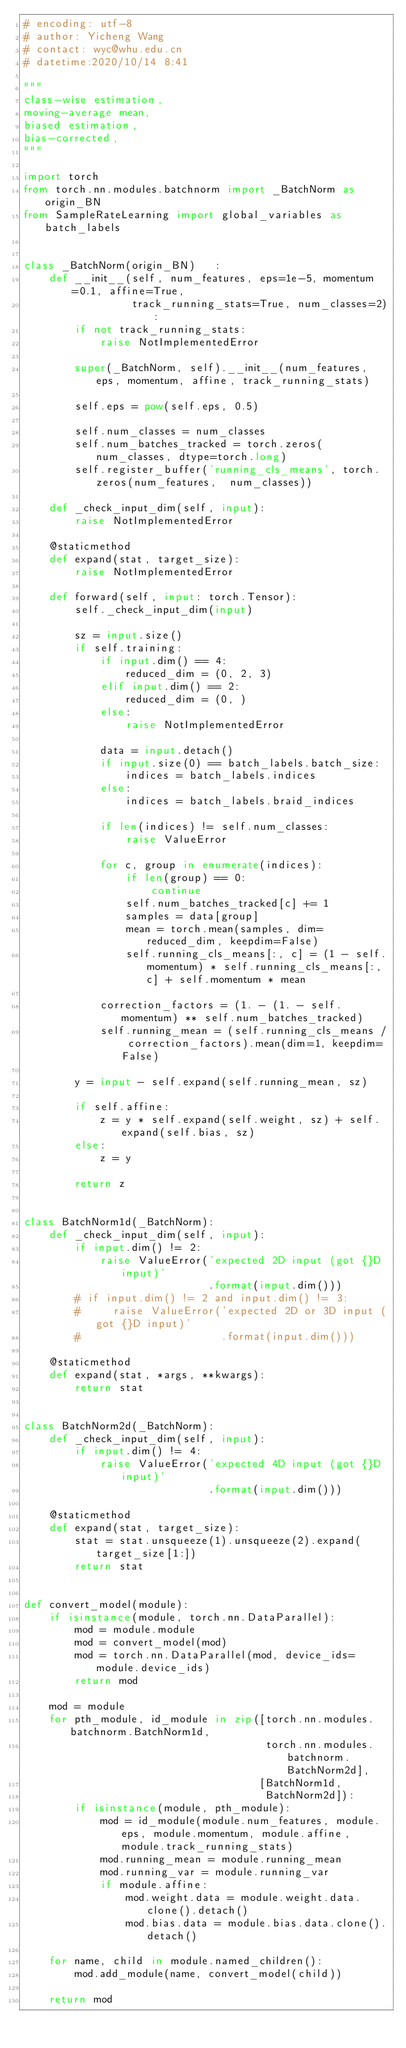<code> <loc_0><loc_0><loc_500><loc_500><_Python_># encoding: utf-8
# author: Yicheng Wang
# contact: wyc@whu.edu.cn
# datetime:2020/10/14 8:41

"""
class-wise estimation,
moving-average mean,
biased estimation,
bias-corrected,
"""

import torch
from torch.nn.modules.batchnorm import _BatchNorm as origin_BN
from SampleRateLearning import global_variables as batch_labels


class _BatchNorm(origin_BN)   :
    def __init__(self, num_features, eps=1e-5, momentum=0.1, affine=True,
                 track_running_stats=True, num_classes=2):
        if not track_running_stats:
            raise NotImplementedError

        super(_BatchNorm, self).__init__(num_features, eps, momentum, affine, track_running_stats)

        self.eps = pow(self.eps, 0.5)

        self.num_classes = num_classes
        self.num_batches_tracked = torch.zeros(num_classes, dtype=torch.long)
        self.register_buffer('running_cls_means', torch.zeros(num_features,  num_classes))

    def _check_input_dim(self, input):
        raise NotImplementedError

    @staticmethod
    def expand(stat, target_size):
        raise NotImplementedError

    def forward(self, input: torch.Tensor):
        self._check_input_dim(input)

        sz = input.size()
        if self.training:
            if input.dim() == 4:
                reduced_dim = (0, 2, 3)
            elif input.dim() == 2:
                reduced_dim = (0, )
            else:
                raise NotImplementedError

            data = input.detach()
            if input.size(0) == batch_labels.batch_size:
                indices = batch_labels.indices
            else:
                indices = batch_labels.braid_indices

            if len(indices) != self.num_classes:
                raise ValueError

            for c, group in enumerate(indices):
                if len(group) == 0:
                    continue
                self.num_batches_tracked[c] += 1
                samples = data[group]
                mean = torch.mean(samples, dim=reduced_dim, keepdim=False)
                self.running_cls_means[:, c] = (1 - self.momentum) * self.running_cls_means[:, c] + self.momentum * mean

            correction_factors = (1. - (1. - self.momentum) ** self.num_batches_tracked)
            self.running_mean = (self.running_cls_means / correction_factors).mean(dim=1, keepdim=False)

        y = input - self.expand(self.running_mean, sz)

        if self.affine:
            z = y * self.expand(self.weight, sz) + self.expand(self.bias, sz)
        else:
            z = y

        return z


class BatchNorm1d(_BatchNorm):
    def _check_input_dim(self, input):
        if input.dim() != 2:
            raise ValueError('expected 2D input (got {}D input)'
                             .format(input.dim()))
        # if input.dim() != 2 and input.dim() != 3:
        #     raise ValueError('expected 2D or 3D input (got {}D input)'
        #                      .format(input.dim()))

    @staticmethod
    def expand(stat, *args, **kwargs):
        return stat


class BatchNorm2d(_BatchNorm):
    def _check_input_dim(self, input):
        if input.dim() != 4:
            raise ValueError('expected 4D input (got {}D input)'
                             .format(input.dim()))

    @staticmethod
    def expand(stat, target_size):
        stat = stat.unsqueeze(1).unsqueeze(2).expand(target_size[1:])
        return stat


def convert_model(module):
    if isinstance(module, torch.nn.DataParallel):
        mod = module.module
        mod = convert_model(mod)
        mod = torch.nn.DataParallel(mod, device_ids=module.device_ids)
        return mod

    mod = module
    for pth_module, id_module in zip([torch.nn.modules.batchnorm.BatchNorm1d,
                                      torch.nn.modules.batchnorm.BatchNorm2d],
                                     [BatchNorm1d,
                                      BatchNorm2d]):
        if isinstance(module, pth_module):
            mod = id_module(module.num_features, module.eps, module.momentum, module.affine, module.track_running_stats)
            mod.running_mean = module.running_mean
            mod.running_var = module.running_var
            if module.affine:
                mod.weight.data = module.weight.data.clone().detach()
                mod.bias.data = module.bias.data.clone().detach()

    for name, child in module.named_children():
        mod.add_module(name, convert_model(child))

    return mod
</code> 